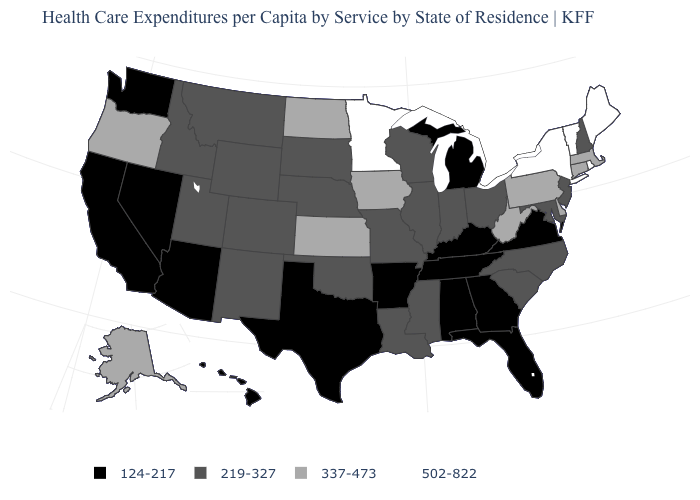Which states hav the highest value in the West?
Give a very brief answer. Alaska, Oregon. Which states have the lowest value in the MidWest?
Write a very short answer. Michigan. What is the value of Illinois?
Be succinct. 219-327. What is the value of New Mexico?
Quick response, please. 219-327. Does Washington have a lower value than Wyoming?
Be succinct. Yes. Does Arizona have a higher value than New Jersey?
Give a very brief answer. No. What is the lowest value in the West?
Quick response, please. 124-217. What is the value of Hawaii?
Write a very short answer. 124-217. Does Florida have a higher value than Mississippi?
Concise answer only. No. What is the highest value in the USA?
Keep it brief. 502-822. Name the states that have a value in the range 502-822?
Keep it brief. Maine, Minnesota, New York, Rhode Island, Vermont. Does Alaska have the highest value in the West?
Give a very brief answer. Yes. What is the highest value in states that border West Virginia?
Quick response, please. 337-473. Does North Dakota have a lower value than Arizona?
Answer briefly. No. 